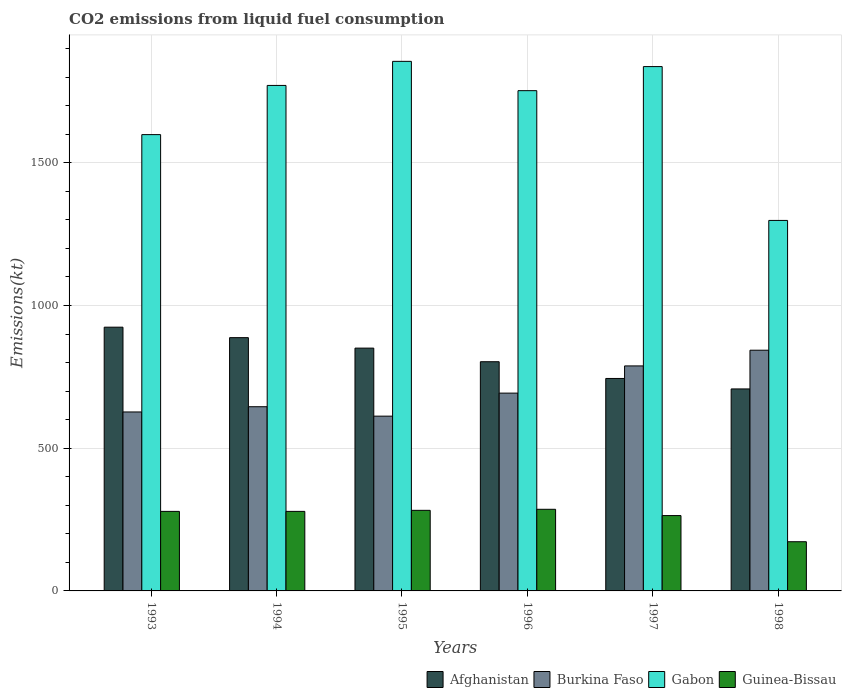How many different coloured bars are there?
Keep it short and to the point. 4. How many groups of bars are there?
Offer a terse response. 6. Are the number of bars per tick equal to the number of legend labels?
Provide a succinct answer. Yes. Are the number of bars on each tick of the X-axis equal?
Provide a succinct answer. Yes. How many bars are there on the 3rd tick from the left?
Give a very brief answer. 4. What is the label of the 1st group of bars from the left?
Give a very brief answer. 1993. What is the amount of CO2 emitted in Afghanistan in 1998?
Offer a very short reply. 707.73. Across all years, what is the maximum amount of CO2 emitted in Burkina Faso?
Give a very brief answer. 843.41. Across all years, what is the minimum amount of CO2 emitted in Gabon?
Keep it short and to the point. 1298.12. In which year was the amount of CO2 emitted in Guinea-Bissau maximum?
Offer a terse response. 1996. In which year was the amount of CO2 emitted in Gabon minimum?
Give a very brief answer. 1998. What is the total amount of CO2 emitted in Burkina Faso in the graph?
Offer a very short reply. 4209.72. What is the difference between the amount of CO2 emitted in Gabon in 1995 and that in 1998?
Provide a succinct answer. 557.38. What is the difference between the amount of CO2 emitted in Afghanistan in 1998 and the amount of CO2 emitted in Guinea-Bissau in 1997?
Give a very brief answer. 443.71. What is the average amount of CO2 emitted in Afghanistan per year?
Give a very brief answer. 819.57. In the year 1998, what is the difference between the amount of CO2 emitted in Burkina Faso and amount of CO2 emitted in Guinea-Bissau?
Your answer should be very brief. 671.06. In how many years, is the amount of CO2 emitted in Gabon greater than 300 kt?
Your response must be concise. 6. What is the ratio of the amount of CO2 emitted in Guinea-Bissau in 1994 to that in 1996?
Offer a terse response. 0.97. Is the difference between the amount of CO2 emitted in Burkina Faso in 1994 and 1995 greater than the difference between the amount of CO2 emitted in Guinea-Bissau in 1994 and 1995?
Give a very brief answer. Yes. What is the difference between the highest and the second highest amount of CO2 emitted in Gabon?
Your answer should be very brief. 18.34. What is the difference between the highest and the lowest amount of CO2 emitted in Gabon?
Offer a very short reply. 557.38. Is the sum of the amount of CO2 emitted in Gabon in 1995 and 1996 greater than the maximum amount of CO2 emitted in Burkina Faso across all years?
Ensure brevity in your answer.  Yes. Is it the case that in every year, the sum of the amount of CO2 emitted in Afghanistan and amount of CO2 emitted in Guinea-Bissau is greater than the sum of amount of CO2 emitted in Gabon and amount of CO2 emitted in Burkina Faso?
Provide a succinct answer. Yes. What does the 4th bar from the left in 1994 represents?
Your answer should be compact. Guinea-Bissau. What does the 4th bar from the right in 1994 represents?
Your answer should be very brief. Afghanistan. How many years are there in the graph?
Your answer should be compact. 6. Are the values on the major ticks of Y-axis written in scientific E-notation?
Provide a short and direct response. No. Does the graph contain any zero values?
Offer a very short reply. No. Does the graph contain grids?
Provide a short and direct response. Yes. Where does the legend appear in the graph?
Make the answer very short. Bottom right. How many legend labels are there?
Offer a terse response. 4. How are the legend labels stacked?
Give a very brief answer. Horizontal. What is the title of the graph?
Provide a succinct answer. CO2 emissions from liquid fuel consumption. What is the label or title of the X-axis?
Your answer should be compact. Years. What is the label or title of the Y-axis?
Your response must be concise. Emissions(kt). What is the Emissions(kt) of Afghanistan in 1993?
Provide a succinct answer. 924.08. What is the Emissions(kt) of Burkina Faso in 1993?
Provide a succinct answer. 627.06. What is the Emissions(kt) in Gabon in 1993?
Provide a succinct answer. 1598.81. What is the Emissions(kt) in Guinea-Bissau in 1993?
Give a very brief answer. 278.69. What is the Emissions(kt) in Afghanistan in 1994?
Offer a very short reply. 887.41. What is the Emissions(kt) in Burkina Faso in 1994?
Ensure brevity in your answer.  645.39. What is the Emissions(kt) in Gabon in 1994?
Provide a short and direct response. 1771.16. What is the Emissions(kt) in Guinea-Bissau in 1994?
Provide a short and direct response. 278.69. What is the Emissions(kt) in Afghanistan in 1995?
Keep it short and to the point. 850.74. What is the Emissions(kt) of Burkina Faso in 1995?
Offer a terse response. 612.39. What is the Emissions(kt) in Gabon in 1995?
Your response must be concise. 1855.5. What is the Emissions(kt) in Guinea-Bissau in 1995?
Give a very brief answer. 282.36. What is the Emissions(kt) of Afghanistan in 1996?
Ensure brevity in your answer.  803.07. What is the Emissions(kt) of Burkina Faso in 1996?
Make the answer very short. 693.06. What is the Emissions(kt) of Gabon in 1996?
Ensure brevity in your answer.  1752.83. What is the Emissions(kt) of Guinea-Bissau in 1996?
Offer a terse response. 286.03. What is the Emissions(kt) of Afghanistan in 1997?
Provide a short and direct response. 744.4. What is the Emissions(kt) of Burkina Faso in 1997?
Keep it short and to the point. 788.4. What is the Emissions(kt) in Gabon in 1997?
Provide a short and direct response. 1837.17. What is the Emissions(kt) in Guinea-Bissau in 1997?
Keep it short and to the point. 264.02. What is the Emissions(kt) in Afghanistan in 1998?
Provide a short and direct response. 707.73. What is the Emissions(kt) of Burkina Faso in 1998?
Offer a terse response. 843.41. What is the Emissions(kt) of Gabon in 1998?
Your response must be concise. 1298.12. What is the Emissions(kt) of Guinea-Bissau in 1998?
Ensure brevity in your answer.  172.35. Across all years, what is the maximum Emissions(kt) in Afghanistan?
Ensure brevity in your answer.  924.08. Across all years, what is the maximum Emissions(kt) of Burkina Faso?
Your answer should be compact. 843.41. Across all years, what is the maximum Emissions(kt) of Gabon?
Your response must be concise. 1855.5. Across all years, what is the maximum Emissions(kt) of Guinea-Bissau?
Make the answer very short. 286.03. Across all years, what is the minimum Emissions(kt) in Afghanistan?
Give a very brief answer. 707.73. Across all years, what is the minimum Emissions(kt) of Burkina Faso?
Keep it short and to the point. 612.39. Across all years, what is the minimum Emissions(kt) of Gabon?
Give a very brief answer. 1298.12. Across all years, what is the minimum Emissions(kt) in Guinea-Bissau?
Give a very brief answer. 172.35. What is the total Emissions(kt) of Afghanistan in the graph?
Provide a short and direct response. 4917.45. What is the total Emissions(kt) in Burkina Faso in the graph?
Offer a very short reply. 4209.72. What is the total Emissions(kt) in Gabon in the graph?
Ensure brevity in your answer.  1.01e+04. What is the total Emissions(kt) in Guinea-Bissau in the graph?
Make the answer very short. 1562.14. What is the difference between the Emissions(kt) in Afghanistan in 1993 and that in 1994?
Make the answer very short. 36.67. What is the difference between the Emissions(kt) of Burkina Faso in 1993 and that in 1994?
Provide a succinct answer. -18.34. What is the difference between the Emissions(kt) in Gabon in 1993 and that in 1994?
Offer a terse response. -172.35. What is the difference between the Emissions(kt) of Guinea-Bissau in 1993 and that in 1994?
Your answer should be very brief. 0. What is the difference between the Emissions(kt) in Afghanistan in 1993 and that in 1995?
Keep it short and to the point. 73.34. What is the difference between the Emissions(kt) in Burkina Faso in 1993 and that in 1995?
Your answer should be compact. 14.67. What is the difference between the Emissions(kt) of Gabon in 1993 and that in 1995?
Offer a very short reply. -256.69. What is the difference between the Emissions(kt) in Guinea-Bissau in 1993 and that in 1995?
Ensure brevity in your answer.  -3.67. What is the difference between the Emissions(kt) in Afghanistan in 1993 and that in 1996?
Keep it short and to the point. 121.01. What is the difference between the Emissions(kt) of Burkina Faso in 1993 and that in 1996?
Offer a very short reply. -66.01. What is the difference between the Emissions(kt) of Gabon in 1993 and that in 1996?
Your answer should be very brief. -154.01. What is the difference between the Emissions(kt) in Guinea-Bissau in 1993 and that in 1996?
Make the answer very short. -7.33. What is the difference between the Emissions(kt) of Afghanistan in 1993 and that in 1997?
Provide a short and direct response. 179.68. What is the difference between the Emissions(kt) in Burkina Faso in 1993 and that in 1997?
Give a very brief answer. -161.35. What is the difference between the Emissions(kt) in Gabon in 1993 and that in 1997?
Give a very brief answer. -238.35. What is the difference between the Emissions(kt) of Guinea-Bissau in 1993 and that in 1997?
Provide a short and direct response. 14.67. What is the difference between the Emissions(kt) of Afghanistan in 1993 and that in 1998?
Keep it short and to the point. 216.35. What is the difference between the Emissions(kt) in Burkina Faso in 1993 and that in 1998?
Your answer should be very brief. -216.35. What is the difference between the Emissions(kt) of Gabon in 1993 and that in 1998?
Your response must be concise. 300.69. What is the difference between the Emissions(kt) in Guinea-Bissau in 1993 and that in 1998?
Your response must be concise. 106.34. What is the difference between the Emissions(kt) in Afghanistan in 1994 and that in 1995?
Give a very brief answer. 36.67. What is the difference between the Emissions(kt) of Burkina Faso in 1994 and that in 1995?
Your answer should be compact. 33. What is the difference between the Emissions(kt) of Gabon in 1994 and that in 1995?
Provide a succinct answer. -84.34. What is the difference between the Emissions(kt) in Guinea-Bissau in 1994 and that in 1995?
Give a very brief answer. -3.67. What is the difference between the Emissions(kt) in Afghanistan in 1994 and that in 1996?
Your answer should be compact. 84.34. What is the difference between the Emissions(kt) in Burkina Faso in 1994 and that in 1996?
Your response must be concise. -47.67. What is the difference between the Emissions(kt) in Gabon in 1994 and that in 1996?
Make the answer very short. 18.34. What is the difference between the Emissions(kt) of Guinea-Bissau in 1994 and that in 1996?
Give a very brief answer. -7.33. What is the difference between the Emissions(kt) in Afghanistan in 1994 and that in 1997?
Offer a very short reply. 143.01. What is the difference between the Emissions(kt) in Burkina Faso in 1994 and that in 1997?
Give a very brief answer. -143.01. What is the difference between the Emissions(kt) in Gabon in 1994 and that in 1997?
Provide a succinct answer. -66.01. What is the difference between the Emissions(kt) in Guinea-Bissau in 1994 and that in 1997?
Keep it short and to the point. 14.67. What is the difference between the Emissions(kt) of Afghanistan in 1994 and that in 1998?
Your response must be concise. 179.68. What is the difference between the Emissions(kt) of Burkina Faso in 1994 and that in 1998?
Provide a short and direct response. -198.02. What is the difference between the Emissions(kt) in Gabon in 1994 and that in 1998?
Your response must be concise. 473.04. What is the difference between the Emissions(kt) of Guinea-Bissau in 1994 and that in 1998?
Your answer should be compact. 106.34. What is the difference between the Emissions(kt) of Afghanistan in 1995 and that in 1996?
Keep it short and to the point. 47.67. What is the difference between the Emissions(kt) in Burkina Faso in 1995 and that in 1996?
Offer a terse response. -80.67. What is the difference between the Emissions(kt) in Gabon in 1995 and that in 1996?
Ensure brevity in your answer.  102.68. What is the difference between the Emissions(kt) in Guinea-Bissau in 1995 and that in 1996?
Provide a succinct answer. -3.67. What is the difference between the Emissions(kt) in Afghanistan in 1995 and that in 1997?
Ensure brevity in your answer.  106.34. What is the difference between the Emissions(kt) of Burkina Faso in 1995 and that in 1997?
Your response must be concise. -176.02. What is the difference between the Emissions(kt) of Gabon in 1995 and that in 1997?
Provide a short and direct response. 18.34. What is the difference between the Emissions(kt) in Guinea-Bissau in 1995 and that in 1997?
Offer a terse response. 18.34. What is the difference between the Emissions(kt) in Afghanistan in 1995 and that in 1998?
Keep it short and to the point. 143.01. What is the difference between the Emissions(kt) of Burkina Faso in 1995 and that in 1998?
Keep it short and to the point. -231.02. What is the difference between the Emissions(kt) in Gabon in 1995 and that in 1998?
Provide a succinct answer. 557.38. What is the difference between the Emissions(kt) of Guinea-Bissau in 1995 and that in 1998?
Your response must be concise. 110.01. What is the difference between the Emissions(kt) of Afghanistan in 1996 and that in 1997?
Provide a succinct answer. 58.67. What is the difference between the Emissions(kt) of Burkina Faso in 1996 and that in 1997?
Give a very brief answer. -95.34. What is the difference between the Emissions(kt) of Gabon in 1996 and that in 1997?
Your answer should be compact. -84.34. What is the difference between the Emissions(kt) of Guinea-Bissau in 1996 and that in 1997?
Provide a short and direct response. 22. What is the difference between the Emissions(kt) of Afghanistan in 1996 and that in 1998?
Your answer should be compact. 95.34. What is the difference between the Emissions(kt) in Burkina Faso in 1996 and that in 1998?
Keep it short and to the point. -150.35. What is the difference between the Emissions(kt) of Gabon in 1996 and that in 1998?
Provide a short and direct response. 454.71. What is the difference between the Emissions(kt) in Guinea-Bissau in 1996 and that in 1998?
Ensure brevity in your answer.  113.68. What is the difference between the Emissions(kt) of Afghanistan in 1997 and that in 1998?
Offer a terse response. 36.67. What is the difference between the Emissions(kt) in Burkina Faso in 1997 and that in 1998?
Give a very brief answer. -55.01. What is the difference between the Emissions(kt) of Gabon in 1997 and that in 1998?
Make the answer very short. 539.05. What is the difference between the Emissions(kt) of Guinea-Bissau in 1997 and that in 1998?
Your answer should be very brief. 91.67. What is the difference between the Emissions(kt) in Afghanistan in 1993 and the Emissions(kt) in Burkina Faso in 1994?
Give a very brief answer. 278.69. What is the difference between the Emissions(kt) in Afghanistan in 1993 and the Emissions(kt) in Gabon in 1994?
Offer a terse response. -847.08. What is the difference between the Emissions(kt) in Afghanistan in 1993 and the Emissions(kt) in Guinea-Bissau in 1994?
Your answer should be very brief. 645.39. What is the difference between the Emissions(kt) of Burkina Faso in 1993 and the Emissions(kt) of Gabon in 1994?
Your response must be concise. -1144.1. What is the difference between the Emissions(kt) of Burkina Faso in 1993 and the Emissions(kt) of Guinea-Bissau in 1994?
Offer a terse response. 348.37. What is the difference between the Emissions(kt) in Gabon in 1993 and the Emissions(kt) in Guinea-Bissau in 1994?
Give a very brief answer. 1320.12. What is the difference between the Emissions(kt) in Afghanistan in 1993 and the Emissions(kt) in Burkina Faso in 1995?
Provide a short and direct response. 311.69. What is the difference between the Emissions(kt) in Afghanistan in 1993 and the Emissions(kt) in Gabon in 1995?
Provide a short and direct response. -931.42. What is the difference between the Emissions(kt) of Afghanistan in 1993 and the Emissions(kt) of Guinea-Bissau in 1995?
Provide a short and direct response. 641.73. What is the difference between the Emissions(kt) in Burkina Faso in 1993 and the Emissions(kt) in Gabon in 1995?
Your answer should be very brief. -1228.44. What is the difference between the Emissions(kt) in Burkina Faso in 1993 and the Emissions(kt) in Guinea-Bissau in 1995?
Make the answer very short. 344.7. What is the difference between the Emissions(kt) of Gabon in 1993 and the Emissions(kt) of Guinea-Bissau in 1995?
Give a very brief answer. 1316.45. What is the difference between the Emissions(kt) of Afghanistan in 1993 and the Emissions(kt) of Burkina Faso in 1996?
Offer a terse response. 231.02. What is the difference between the Emissions(kt) in Afghanistan in 1993 and the Emissions(kt) in Gabon in 1996?
Your response must be concise. -828.74. What is the difference between the Emissions(kt) in Afghanistan in 1993 and the Emissions(kt) in Guinea-Bissau in 1996?
Give a very brief answer. 638.06. What is the difference between the Emissions(kt) of Burkina Faso in 1993 and the Emissions(kt) of Gabon in 1996?
Make the answer very short. -1125.77. What is the difference between the Emissions(kt) in Burkina Faso in 1993 and the Emissions(kt) in Guinea-Bissau in 1996?
Give a very brief answer. 341.03. What is the difference between the Emissions(kt) in Gabon in 1993 and the Emissions(kt) in Guinea-Bissau in 1996?
Your response must be concise. 1312.79. What is the difference between the Emissions(kt) of Afghanistan in 1993 and the Emissions(kt) of Burkina Faso in 1997?
Keep it short and to the point. 135.68. What is the difference between the Emissions(kt) in Afghanistan in 1993 and the Emissions(kt) in Gabon in 1997?
Offer a terse response. -913.08. What is the difference between the Emissions(kt) in Afghanistan in 1993 and the Emissions(kt) in Guinea-Bissau in 1997?
Offer a terse response. 660.06. What is the difference between the Emissions(kt) of Burkina Faso in 1993 and the Emissions(kt) of Gabon in 1997?
Ensure brevity in your answer.  -1210.11. What is the difference between the Emissions(kt) in Burkina Faso in 1993 and the Emissions(kt) in Guinea-Bissau in 1997?
Give a very brief answer. 363.03. What is the difference between the Emissions(kt) in Gabon in 1993 and the Emissions(kt) in Guinea-Bissau in 1997?
Your answer should be very brief. 1334.79. What is the difference between the Emissions(kt) in Afghanistan in 1993 and the Emissions(kt) in Burkina Faso in 1998?
Ensure brevity in your answer.  80.67. What is the difference between the Emissions(kt) in Afghanistan in 1993 and the Emissions(kt) in Gabon in 1998?
Offer a terse response. -374.03. What is the difference between the Emissions(kt) of Afghanistan in 1993 and the Emissions(kt) of Guinea-Bissau in 1998?
Your answer should be compact. 751.74. What is the difference between the Emissions(kt) of Burkina Faso in 1993 and the Emissions(kt) of Gabon in 1998?
Ensure brevity in your answer.  -671.06. What is the difference between the Emissions(kt) in Burkina Faso in 1993 and the Emissions(kt) in Guinea-Bissau in 1998?
Offer a terse response. 454.71. What is the difference between the Emissions(kt) in Gabon in 1993 and the Emissions(kt) in Guinea-Bissau in 1998?
Offer a terse response. 1426.46. What is the difference between the Emissions(kt) of Afghanistan in 1994 and the Emissions(kt) of Burkina Faso in 1995?
Your answer should be compact. 275.02. What is the difference between the Emissions(kt) of Afghanistan in 1994 and the Emissions(kt) of Gabon in 1995?
Provide a succinct answer. -968.09. What is the difference between the Emissions(kt) in Afghanistan in 1994 and the Emissions(kt) in Guinea-Bissau in 1995?
Provide a succinct answer. 605.05. What is the difference between the Emissions(kt) of Burkina Faso in 1994 and the Emissions(kt) of Gabon in 1995?
Offer a very short reply. -1210.11. What is the difference between the Emissions(kt) in Burkina Faso in 1994 and the Emissions(kt) in Guinea-Bissau in 1995?
Provide a succinct answer. 363.03. What is the difference between the Emissions(kt) of Gabon in 1994 and the Emissions(kt) of Guinea-Bissau in 1995?
Your answer should be very brief. 1488.8. What is the difference between the Emissions(kt) of Afghanistan in 1994 and the Emissions(kt) of Burkina Faso in 1996?
Make the answer very short. 194.35. What is the difference between the Emissions(kt) of Afghanistan in 1994 and the Emissions(kt) of Gabon in 1996?
Your answer should be very brief. -865.41. What is the difference between the Emissions(kt) of Afghanistan in 1994 and the Emissions(kt) of Guinea-Bissau in 1996?
Your answer should be compact. 601.39. What is the difference between the Emissions(kt) of Burkina Faso in 1994 and the Emissions(kt) of Gabon in 1996?
Your answer should be compact. -1107.43. What is the difference between the Emissions(kt) of Burkina Faso in 1994 and the Emissions(kt) of Guinea-Bissau in 1996?
Offer a terse response. 359.37. What is the difference between the Emissions(kt) of Gabon in 1994 and the Emissions(kt) of Guinea-Bissau in 1996?
Make the answer very short. 1485.13. What is the difference between the Emissions(kt) of Afghanistan in 1994 and the Emissions(kt) of Burkina Faso in 1997?
Ensure brevity in your answer.  99.01. What is the difference between the Emissions(kt) in Afghanistan in 1994 and the Emissions(kt) in Gabon in 1997?
Your answer should be compact. -949.75. What is the difference between the Emissions(kt) of Afghanistan in 1994 and the Emissions(kt) of Guinea-Bissau in 1997?
Make the answer very short. 623.39. What is the difference between the Emissions(kt) of Burkina Faso in 1994 and the Emissions(kt) of Gabon in 1997?
Provide a succinct answer. -1191.78. What is the difference between the Emissions(kt) of Burkina Faso in 1994 and the Emissions(kt) of Guinea-Bissau in 1997?
Make the answer very short. 381.37. What is the difference between the Emissions(kt) in Gabon in 1994 and the Emissions(kt) in Guinea-Bissau in 1997?
Keep it short and to the point. 1507.14. What is the difference between the Emissions(kt) of Afghanistan in 1994 and the Emissions(kt) of Burkina Faso in 1998?
Your answer should be very brief. 44. What is the difference between the Emissions(kt) of Afghanistan in 1994 and the Emissions(kt) of Gabon in 1998?
Your answer should be compact. -410.7. What is the difference between the Emissions(kt) of Afghanistan in 1994 and the Emissions(kt) of Guinea-Bissau in 1998?
Provide a short and direct response. 715.07. What is the difference between the Emissions(kt) of Burkina Faso in 1994 and the Emissions(kt) of Gabon in 1998?
Provide a short and direct response. -652.73. What is the difference between the Emissions(kt) in Burkina Faso in 1994 and the Emissions(kt) in Guinea-Bissau in 1998?
Give a very brief answer. 473.04. What is the difference between the Emissions(kt) in Gabon in 1994 and the Emissions(kt) in Guinea-Bissau in 1998?
Give a very brief answer. 1598.81. What is the difference between the Emissions(kt) in Afghanistan in 1995 and the Emissions(kt) in Burkina Faso in 1996?
Give a very brief answer. 157.68. What is the difference between the Emissions(kt) of Afghanistan in 1995 and the Emissions(kt) of Gabon in 1996?
Provide a succinct answer. -902.08. What is the difference between the Emissions(kt) of Afghanistan in 1995 and the Emissions(kt) of Guinea-Bissau in 1996?
Provide a short and direct response. 564.72. What is the difference between the Emissions(kt) in Burkina Faso in 1995 and the Emissions(kt) in Gabon in 1996?
Make the answer very short. -1140.44. What is the difference between the Emissions(kt) of Burkina Faso in 1995 and the Emissions(kt) of Guinea-Bissau in 1996?
Provide a short and direct response. 326.36. What is the difference between the Emissions(kt) in Gabon in 1995 and the Emissions(kt) in Guinea-Bissau in 1996?
Make the answer very short. 1569.48. What is the difference between the Emissions(kt) of Afghanistan in 1995 and the Emissions(kt) of Burkina Faso in 1997?
Your response must be concise. 62.34. What is the difference between the Emissions(kt) of Afghanistan in 1995 and the Emissions(kt) of Gabon in 1997?
Offer a very short reply. -986.42. What is the difference between the Emissions(kt) in Afghanistan in 1995 and the Emissions(kt) in Guinea-Bissau in 1997?
Provide a short and direct response. 586.72. What is the difference between the Emissions(kt) in Burkina Faso in 1995 and the Emissions(kt) in Gabon in 1997?
Provide a short and direct response. -1224.78. What is the difference between the Emissions(kt) in Burkina Faso in 1995 and the Emissions(kt) in Guinea-Bissau in 1997?
Your answer should be very brief. 348.37. What is the difference between the Emissions(kt) of Gabon in 1995 and the Emissions(kt) of Guinea-Bissau in 1997?
Provide a short and direct response. 1591.48. What is the difference between the Emissions(kt) in Afghanistan in 1995 and the Emissions(kt) in Burkina Faso in 1998?
Provide a short and direct response. 7.33. What is the difference between the Emissions(kt) of Afghanistan in 1995 and the Emissions(kt) of Gabon in 1998?
Keep it short and to the point. -447.37. What is the difference between the Emissions(kt) in Afghanistan in 1995 and the Emissions(kt) in Guinea-Bissau in 1998?
Provide a succinct answer. 678.39. What is the difference between the Emissions(kt) in Burkina Faso in 1995 and the Emissions(kt) in Gabon in 1998?
Provide a succinct answer. -685.73. What is the difference between the Emissions(kt) in Burkina Faso in 1995 and the Emissions(kt) in Guinea-Bissau in 1998?
Provide a succinct answer. 440.04. What is the difference between the Emissions(kt) in Gabon in 1995 and the Emissions(kt) in Guinea-Bissau in 1998?
Provide a succinct answer. 1683.15. What is the difference between the Emissions(kt) of Afghanistan in 1996 and the Emissions(kt) of Burkina Faso in 1997?
Keep it short and to the point. 14.67. What is the difference between the Emissions(kt) of Afghanistan in 1996 and the Emissions(kt) of Gabon in 1997?
Provide a succinct answer. -1034.09. What is the difference between the Emissions(kt) of Afghanistan in 1996 and the Emissions(kt) of Guinea-Bissau in 1997?
Your response must be concise. 539.05. What is the difference between the Emissions(kt) of Burkina Faso in 1996 and the Emissions(kt) of Gabon in 1997?
Provide a succinct answer. -1144.1. What is the difference between the Emissions(kt) in Burkina Faso in 1996 and the Emissions(kt) in Guinea-Bissau in 1997?
Make the answer very short. 429.04. What is the difference between the Emissions(kt) in Gabon in 1996 and the Emissions(kt) in Guinea-Bissau in 1997?
Your answer should be very brief. 1488.8. What is the difference between the Emissions(kt) in Afghanistan in 1996 and the Emissions(kt) in Burkina Faso in 1998?
Make the answer very short. -40.34. What is the difference between the Emissions(kt) in Afghanistan in 1996 and the Emissions(kt) in Gabon in 1998?
Your answer should be compact. -495.05. What is the difference between the Emissions(kt) of Afghanistan in 1996 and the Emissions(kt) of Guinea-Bissau in 1998?
Provide a short and direct response. 630.72. What is the difference between the Emissions(kt) of Burkina Faso in 1996 and the Emissions(kt) of Gabon in 1998?
Provide a short and direct response. -605.05. What is the difference between the Emissions(kt) of Burkina Faso in 1996 and the Emissions(kt) of Guinea-Bissau in 1998?
Provide a short and direct response. 520.71. What is the difference between the Emissions(kt) of Gabon in 1996 and the Emissions(kt) of Guinea-Bissau in 1998?
Offer a terse response. 1580.48. What is the difference between the Emissions(kt) of Afghanistan in 1997 and the Emissions(kt) of Burkina Faso in 1998?
Your answer should be compact. -99.01. What is the difference between the Emissions(kt) in Afghanistan in 1997 and the Emissions(kt) in Gabon in 1998?
Provide a short and direct response. -553.72. What is the difference between the Emissions(kt) in Afghanistan in 1997 and the Emissions(kt) in Guinea-Bissau in 1998?
Your answer should be compact. 572.05. What is the difference between the Emissions(kt) in Burkina Faso in 1997 and the Emissions(kt) in Gabon in 1998?
Your answer should be compact. -509.71. What is the difference between the Emissions(kt) in Burkina Faso in 1997 and the Emissions(kt) in Guinea-Bissau in 1998?
Make the answer very short. 616.06. What is the difference between the Emissions(kt) in Gabon in 1997 and the Emissions(kt) in Guinea-Bissau in 1998?
Make the answer very short. 1664.82. What is the average Emissions(kt) in Afghanistan per year?
Keep it short and to the point. 819.57. What is the average Emissions(kt) of Burkina Faso per year?
Ensure brevity in your answer.  701.62. What is the average Emissions(kt) of Gabon per year?
Provide a short and direct response. 1685.6. What is the average Emissions(kt) of Guinea-Bissau per year?
Offer a very short reply. 260.36. In the year 1993, what is the difference between the Emissions(kt) of Afghanistan and Emissions(kt) of Burkina Faso?
Your answer should be very brief. 297.03. In the year 1993, what is the difference between the Emissions(kt) in Afghanistan and Emissions(kt) in Gabon?
Make the answer very short. -674.73. In the year 1993, what is the difference between the Emissions(kt) in Afghanistan and Emissions(kt) in Guinea-Bissau?
Keep it short and to the point. 645.39. In the year 1993, what is the difference between the Emissions(kt) in Burkina Faso and Emissions(kt) in Gabon?
Keep it short and to the point. -971.75. In the year 1993, what is the difference between the Emissions(kt) in Burkina Faso and Emissions(kt) in Guinea-Bissau?
Provide a succinct answer. 348.37. In the year 1993, what is the difference between the Emissions(kt) of Gabon and Emissions(kt) of Guinea-Bissau?
Your answer should be compact. 1320.12. In the year 1994, what is the difference between the Emissions(kt) in Afghanistan and Emissions(kt) in Burkina Faso?
Your response must be concise. 242.02. In the year 1994, what is the difference between the Emissions(kt) in Afghanistan and Emissions(kt) in Gabon?
Provide a short and direct response. -883.75. In the year 1994, what is the difference between the Emissions(kt) of Afghanistan and Emissions(kt) of Guinea-Bissau?
Offer a terse response. 608.72. In the year 1994, what is the difference between the Emissions(kt) of Burkina Faso and Emissions(kt) of Gabon?
Provide a succinct answer. -1125.77. In the year 1994, what is the difference between the Emissions(kt) in Burkina Faso and Emissions(kt) in Guinea-Bissau?
Your response must be concise. 366.7. In the year 1994, what is the difference between the Emissions(kt) in Gabon and Emissions(kt) in Guinea-Bissau?
Your answer should be compact. 1492.47. In the year 1995, what is the difference between the Emissions(kt) in Afghanistan and Emissions(kt) in Burkina Faso?
Make the answer very short. 238.35. In the year 1995, what is the difference between the Emissions(kt) of Afghanistan and Emissions(kt) of Gabon?
Your answer should be very brief. -1004.76. In the year 1995, what is the difference between the Emissions(kt) in Afghanistan and Emissions(kt) in Guinea-Bissau?
Give a very brief answer. 568.38. In the year 1995, what is the difference between the Emissions(kt) in Burkina Faso and Emissions(kt) in Gabon?
Your answer should be compact. -1243.11. In the year 1995, what is the difference between the Emissions(kt) of Burkina Faso and Emissions(kt) of Guinea-Bissau?
Offer a very short reply. 330.03. In the year 1995, what is the difference between the Emissions(kt) of Gabon and Emissions(kt) of Guinea-Bissau?
Provide a succinct answer. 1573.14. In the year 1996, what is the difference between the Emissions(kt) of Afghanistan and Emissions(kt) of Burkina Faso?
Provide a short and direct response. 110.01. In the year 1996, what is the difference between the Emissions(kt) in Afghanistan and Emissions(kt) in Gabon?
Offer a terse response. -949.75. In the year 1996, what is the difference between the Emissions(kt) of Afghanistan and Emissions(kt) of Guinea-Bissau?
Keep it short and to the point. 517.05. In the year 1996, what is the difference between the Emissions(kt) of Burkina Faso and Emissions(kt) of Gabon?
Offer a very short reply. -1059.76. In the year 1996, what is the difference between the Emissions(kt) of Burkina Faso and Emissions(kt) of Guinea-Bissau?
Your answer should be compact. 407.04. In the year 1996, what is the difference between the Emissions(kt) in Gabon and Emissions(kt) in Guinea-Bissau?
Give a very brief answer. 1466.8. In the year 1997, what is the difference between the Emissions(kt) in Afghanistan and Emissions(kt) in Burkina Faso?
Offer a terse response. -44. In the year 1997, what is the difference between the Emissions(kt) of Afghanistan and Emissions(kt) of Gabon?
Your answer should be compact. -1092.77. In the year 1997, what is the difference between the Emissions(kt) in Afghanistan and Emissions(kt) in Guinea-Bissau?
Give a very brief answer. 480.38. In the year 1997, what is the difference between the Emissions(kt) in Burkina Faso and Emissions(kt) in Gabon?
Keep it short and to the point. -1048.76. In the year 1997, what is the difference between the Emissions(kt) of Burkina Faso and Emissions(kt) of Guinea-Bissau?
Your answer should be compact. 524.38. In the year 1997, what is the difference between the Emissions(kt) in Gabon and Emissions(kt) in Guinea-Bissau?
Provide a short and direct response. 1573.14. In the year 1998, what is the difference between the Emissions(kt) of Afghanistan and Emissions(kt) of Burkina Faso?
Make the answer very short. -135.68. In the year 1998, what is the difference between the Emissions(kt) of Afghanistan and Emissions(kt) of Gabon?
Provide a short and direct response. -590.39. In the year 1998, what is the difference between the Emissions(kt) of Afghanistan and Emissions(kt) of Guinea-Bissau?
Offer a very short reply. 535.38. In the year 1998, what is the difference between the Emissions(kt) of Burkina Faso and Emissions(kt) of Gabon?
Make the answer very short. -454.71. In the year 1998, what is the difference between the Emissions(kt) of Burkina Faso and Emissions(kt) of Guinea-Bissau?
Offer a terse response. 671.06. In the year 1998, what is the difference between the Emissions(kt) in Gabon and Emissions(kt) in Guinea-Bissau?
Give a very brief answer. 1125.77. What is the ratio of the Emissions(kt) of Afghanistan in 1993 to that in 1994?
Provide a succinct answer. 1.04. What is the ratio of the Emissions(kt) of Burkina Faso in 1993 to that in 1994?
Ensure brevity in your answer.  0.97. What is the ratio of the Emissions(kt) of Gabon in 1993 to that in 1994?
Ensure brevity in your answer.  0.9. What is the ratio of the Emissions(kt) of Afghanistan in 1993 to that in 1995?
Your response must be concise. 1.09. What is the ratio of the Emissions(kt) in Gabon in 1993 to that in 1995?
Your answer should be compact. 0.86. What is the ratio of the Emissions(kt) in Afghanistan in 1993 to that in 1996?
Provide a short and direct response. 1.15. What is the ratio of the Emissions(kt) of Burkina Faso in 1993 to that in 1996?
Give a very brief answer. 0.9. What is the ratio of the Emissions(kt) of Gabon in 1993 to that in 1996?
Give a very brief answer. 0.91. What is the ratio of the Emissions(kt) of Guinea-Bissau in 1993 to that in 1996?
Provide a succinct answer. 0.97. What is the ratio of the Emissions(kt) of Afghanistan in 1993 to that in 1997?
Your answer should be very brief. 1.24. What is the ratio of the Emissions(kt) in Burkina Faso in 1993 to that in 1997?
Offer a terse response. 0.8. What is the ratio of the Emissions(kt) of Gabon in 1993 to that in 1997?
Provide a succinct answer. 0.87. What is the ratio of the Emissions(kt) of Guinea-Bissau in 1993 to that in 1997?
Provide a short and direct response. 1.06. What is the ratio of the Emissions(kt) in Afghanistan in 1993 to that in 1998?
Give a very brief answer. 1.31. What is the ratio of the Emissions(kt) of Burkina Faso in 1993 to that in 1998?
Give a very brief answer. 0.74. What is the ratio of the Emissions(kt) of Gabon in 1993 to that in 1998?
Give a very brief answer. 1.23. What is the ratio of the Emissions(kt) of Guinea-Bissau in 1993 to that in 1998?
Your answer should be very brief. 1.62. What is the ratio of the Emissions(kt) of Afghanistan in 1994 to that in 1995?
Your answer should be very brief. 1.04. What is the ratio of the Emissions(kt) of Burkina Faso in 1994 to that in 1995?
Offer a terse response. 1.05. What is the ratio of the Emissions(kt) in Gabon in 1994 to that in 1995?
Your response must be concise. 0.95. What is the ratio of the Emissions(kt) of Guinea-Bissau in 1994 to that in 1995?
Offer a terse response. 0.99. What is the ratio of the Emissions(kt) in Afghanistan in 1994 to that in 1996?
Give a very brief answer. 1.1. What is the ratio of the Emissions(kt) in Burkina Faso in 1994 to that in 1996?
Provide a short and direct response. 0.93. What is the ratio of the Emissions(kt) of Gabon in 1994 to that in 1996?
Your answer should be compact. 1.01. What is the ratio of the Emissions(kt) of Guinea-Bissau in 1994 to that in 1996?
Your answer should be compact. 0.97. What is the ratio of the Emissions(kt) of Afghanistan in 1994 to that in 1997?
Provide a short and direct response. 1.19. What is the ratio of the Emissions(kt) of Burkina Faso in 1994 to that in 1997?
Give a very brief answer. 0.82. What is the ratio of the Emissions(kt) in Gabon in 1994 to that in 1997?
Keep it short and to the point. 0.96. What is the ratio of the Emissions(kt) of Guinea-Bissau in 1994 to that in 1997?
Offer a very short reply. 1.06. What is the ratio of the Emissions(kt) in Afghanistan in 1994 to that in 1998?
Offer a terse response. 1.25. What is the ratio of the Emissions(kt) in Burkina Faso in 1994 to that in 1998?
Provide a succinct answer. 0.77. What is the ratio of the Emissions(kt) of Gabon in 1994 to that in 1998?
Your answer should be very brief. 1.36. What is the ratio of the Emissions(kt) of Guinea-Bissau in 1994 to that in 1998?
Your answer should be compact. 1.62. What is the ratio of the Emissions(kt) in Afghanistan in 1995 to that in 1996?
Offer a terse response. 1.06. What is the ratio of the Emissions(kt) in Burkina Faso in 1995 to that in 1996?
Your response must be concise. 0.88. What is the ratio of the Emissions(kt) of Gabon in 1995 to that in 1996?
Ensure brevity in your answer.  1.06. What is the ratio of the Emissions(kt) in Guinea-Bissau in 1995 to that in 1996?
Give a very brief answer. 0.99. What is the ratio of the Emissions(kt) of Burkina Faso in 1995 to that in 1997?
Offer a very short reply. 0.78. What is the ratio of the Emissions(kt) of Gabon in 1995 to that in 1997?
Your answer should be compact. 1.01. What is the ratio of the Emissions(kt) in Guinea-Bissau in 1995 to that in 1997?
Give a very brief answer. 1.07. What is the ratio of the Emissions(kt) of Afghanistan in 1995 to that in 1998?
Your response must be concise. 1.2. What is the ratio of the Emissions(kt) in Burkina Faso in 1995 to that in 1998?
Give a very brief answer. 0.73. What is the ratio of the Emissions(kt) in Gabon in 1995 to that in 1998?
Make the answer very short. 1.43. What is the ratio of the Emissions(kt) in Guinea-Bissau in 1995 to that in 1998?
Keep it short and to the point. 1.64. What is the ratio of the Emissions(kt) in Afghanistan in 1996 to that in 1997?
Offer a very short reply. 1.08. What is the ratio of the Emissions(kt) of Burkina Faso in 1996 to that in 1997?
Give a very brief answer. 0.88. What is the ratio of the Emissions(kt) in Gabon in 1996 to that in 1997?
Your answer should be compact. 0.95. What is the ratio of the Emissions(kt) of Afghanistan in 1996 to that in 1998?
Offer a very short reply. 1.13. What is the ratio of the Emissions(kt) of Burkina Faso in 1996 to that in 1998?
Offer a very short reply. 0.82. What is the ratio of the Emissions(kt) of Gabon in 1996 to that in 1998?
Give a very brief answer. 1.35. What is the ratio of the Emissions(kt) of Guinea-Bissau in 1996 to that in 1998?
Ensure brevity in your answer.  1.66. What is the ratio of the Emissions(kt) in Afghanistan in 1997 to that in 1998?
Provide a short and direct response. 1.05. What is the ratio of the Emissions(kt) of Burkina Faso in 1997 to that in 1998?
Your answer should be very brief. 0.93. What is the ratio of the Emissions(kt) in Gabon in 1997 to that in 1998?
Keep it short and to the point. 1.42. What is the ratio of the Emissions(kt) of Guinea-Bissau in 1997 to that in 1998?
Provide a short and direct response. 1.53. What is the difference between the highest and the second highest Emissions(kt) in Afghanistan?
Provide a succinct answer. 36.67. What is the difference between the highest and the second highest Emissions(kt) in Burkina Faso?
Give a very brief answer. 55.01. What is the difference between the highest and the second highest Emissions(kt) of Gabon?
Make the answer very short. 18.34. What is the difference between the highest and the second highest Emissions(kt) in Guinea-Bissau?
Keep it short and to the point. 3.67. What is the difference between the highest and the lowest Emissions(kt) in Afghanistan?
Provide a short and direct response. 216.35. What is the difference between the highest and the lowest Emissions(kt) in Burkina Faso?
Provide a succinct answer. 231.02. What is the difference between the highest and the lowest Emissions(kt) of Gabon?
Keep it short and to the point. 557.38. What is the difference between the highest and the lowest Emissions(kt) of Guinea-Bissau?
Give a very brief answer. 113.68. 